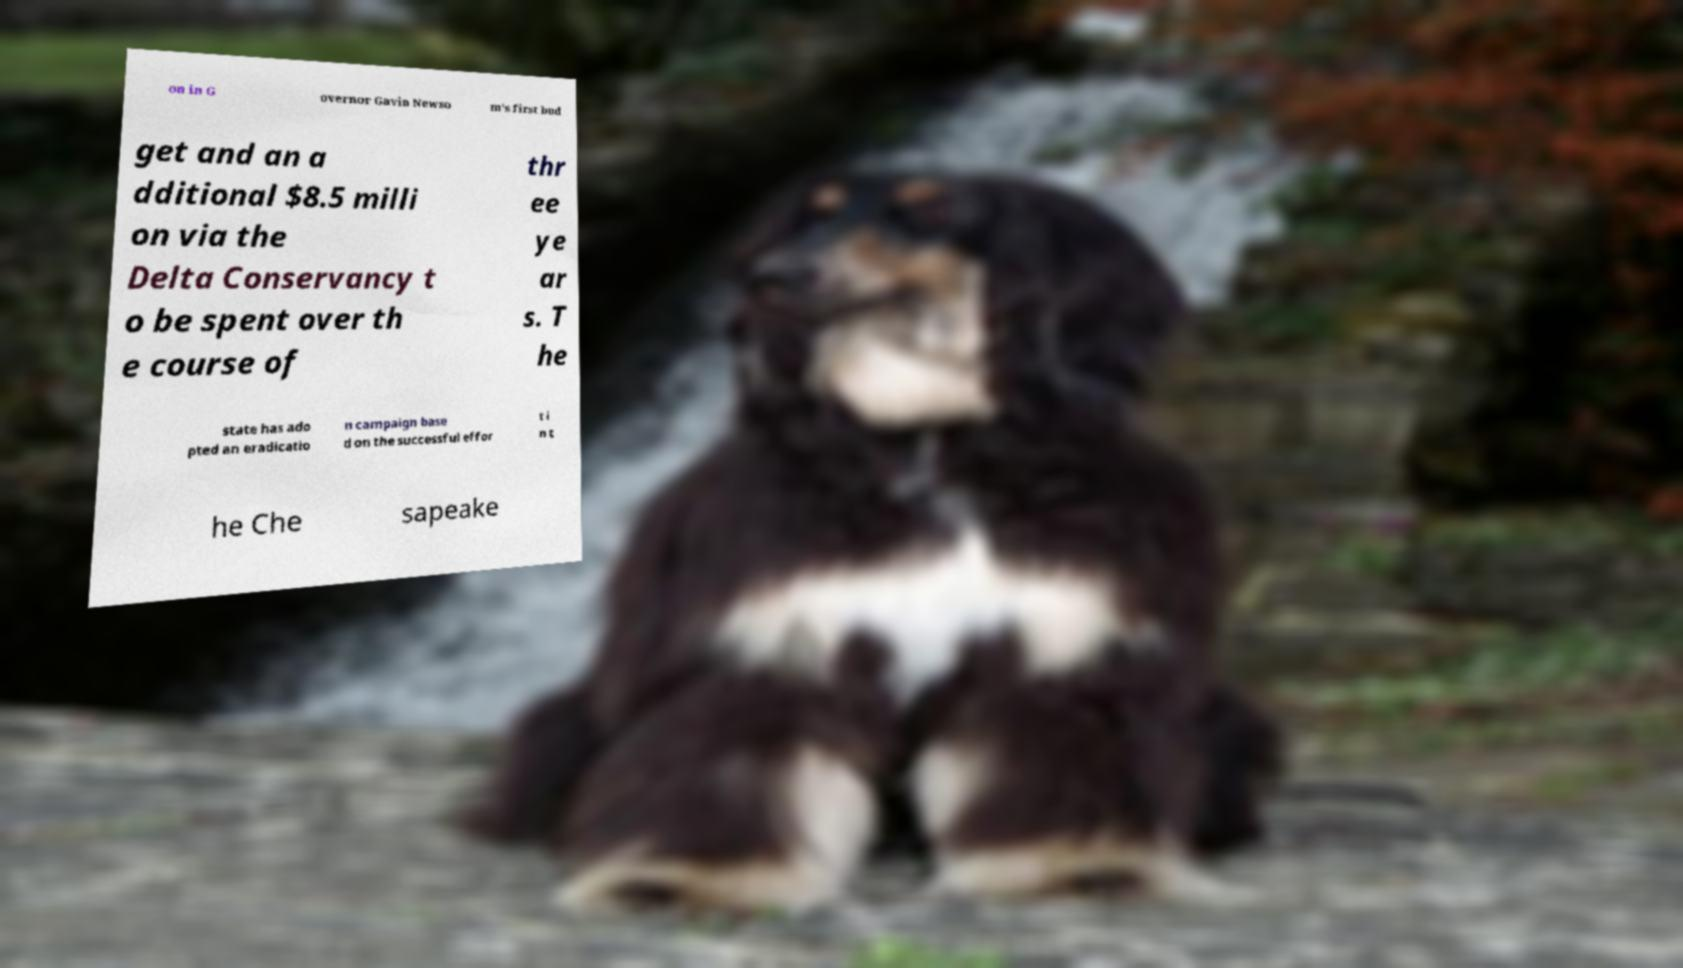Could you extract and type out the text from this image? on in G overnor Gavin Newso m's first bud get and an a dditional $8.5 milli on via the Delta Conservancy t o be spent over th e course of thr ee ye ar s. T he state has ado pted an eradicatio n campaign base d on the successful effor t i n t he Che sapeake 